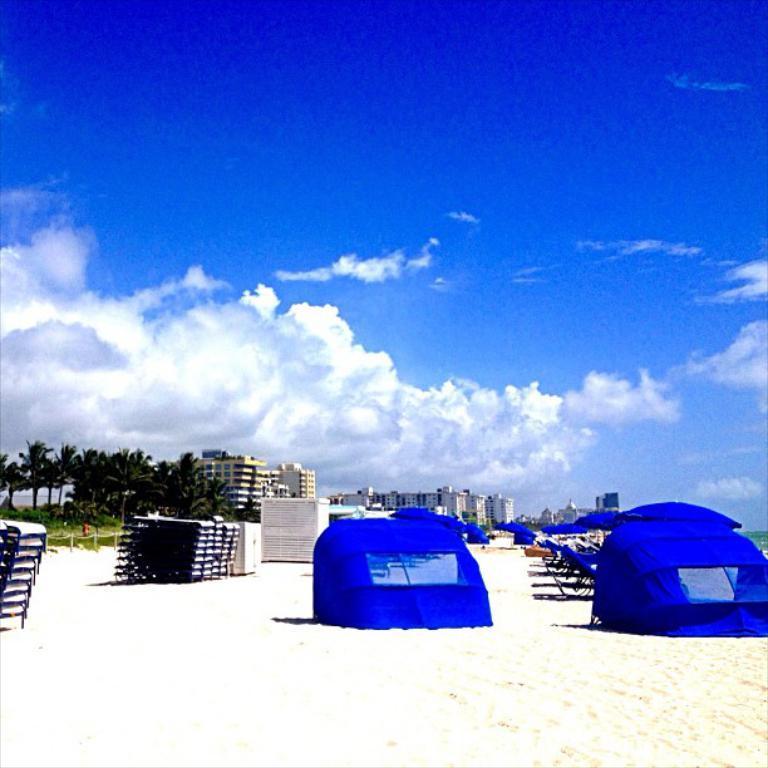In one or two sentences, can you explain what this image depicts? In this image I can see the blue color tents and some objects on the sand. In the background I can see many trees and the buildings. I can also see the clouds and blue sky in the back. 